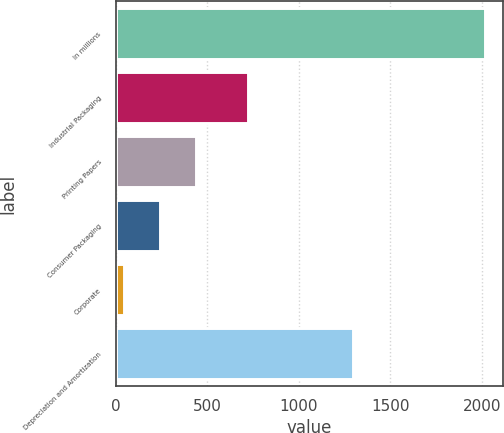Convert chart to OTSL. <chart><loc_0><loc_0><loc_500><loc_500><bar_chart><fcel>In millions<fcel>Industrial Packaging<fcel>Printing Papers<fcel>Consumer Packaging<fcel>Corporate<fcel>Depreciation and Amortization<nl><fcel>2015<fcel>725<fcel>440.6<fcel>243.8<fcel>47<fcel>1294<nl></chart> 